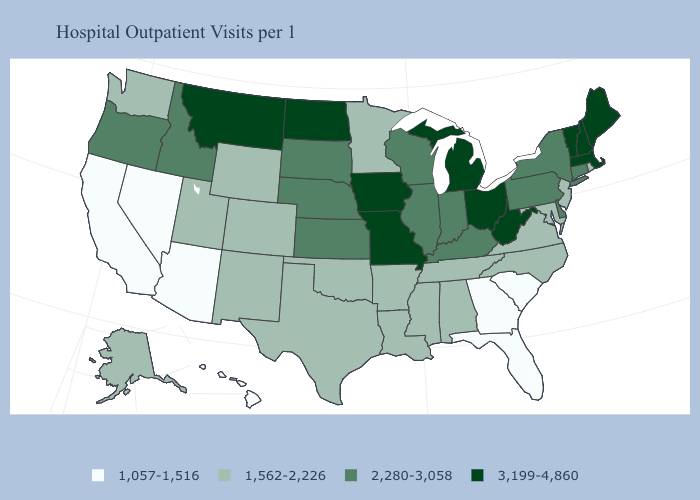Does the first symbol in the legend represent the smallest category?
Short answer required. Yes. Name the states that have a value in the range 3,199-4,860?
Answer briefly. Iowa, Maine, Massachusetts, Michigan, Missouri, Montana, New Hampshire, North Dakota, Ohio, Vermont, West Virginia. Does Georgia have the lowest value in the USA?
Quick response, please. Yes. What is the value of Wyoming?
Keep it brief. 1,562-2,226. Does Oregon have the highest value in the USA?
Concise answer only. No. What is the highest value in the USA?
Give a very brief answer. 3,199-4,860. What is the value of Texas?
Keep it brief. 1,562-2,226. What is the highest value in states that border Idaho?
Short answer required. 3,199-4,860. Name the states that have a value in the range 3,199-4,860?
Be succinct. Iowa, Maine, Massachusetts, Michigan, Missouri, Montana, New Hampshire, North Dakota, Ohio, Vermont, West Virginia. Does South Carolina have a higher value than Oregon?
Keep it brief. No. Name the states that have a value in the range 1,562-2,226?
Keep it brief. Alabama, Alaska, Arkansas, Colorado, Louisiana, Maryland, Minnesota, Mississippi, New Jersey, New Mexico, North Carolina, Oklahoma, Rhode Island, Tennessee, Texas, Utah, Virginia, Washington, Wyoming. Among the states that border Rhode Island , which have the highest value?
Give a very brief answer. Massachusetts. Name the states that have a value in the range 2,280-3,058?
Answer briefly. Connecticut, Delaware, Idaho, Illinois, Indiana, Kansas, Kentucky, Nebraska, New York, Oregon, Pennsylvania, South Dakota, Wisconsin. Which states have the lowest value in the West?
Keep it brief. Arizona, California, Hawaii, Nevada. Name the states that have a value in the range 3,199-4,860?
Quick response, please. Iowa, Maine, Massachusetts, Michigan, Missouri, Montana, New Hampshire, North Dakota, Ohio, Vermont, West Virginia. 